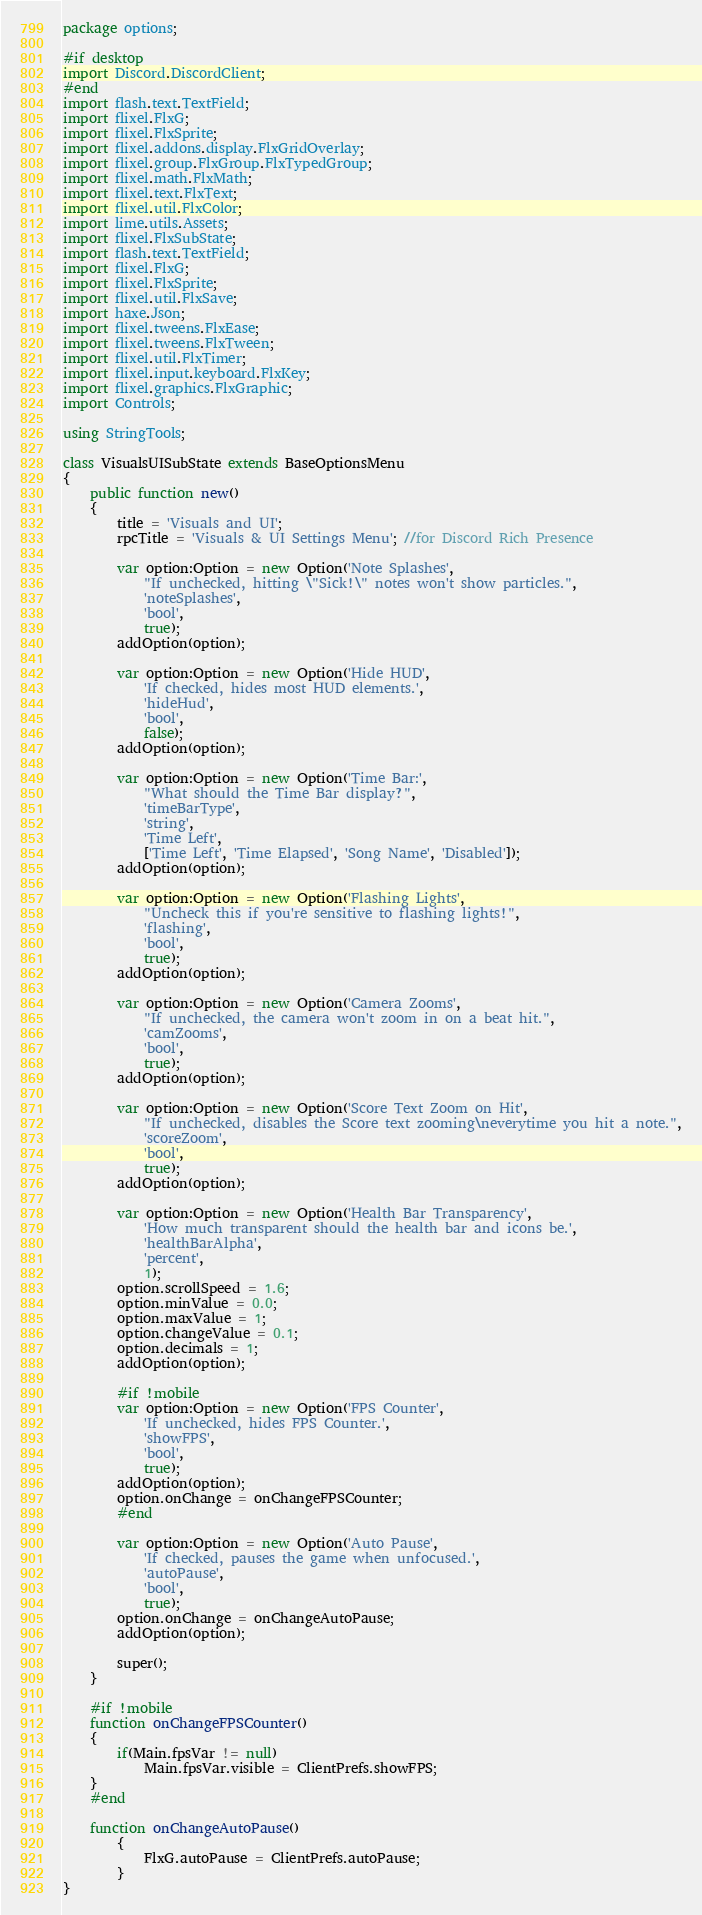<code> <loc_0><loc_0><loc_500><loc_500><_Haxe_>package options;

#if desktop
import Discord.DiscordClient;
#end
import flash.text.TextField;
import flixel.FlxG;
import flixel.FlxSprite;
import flixel.addons.display.FlxGridOverlay;
import flixel.group.FlxGroup.FlxTypedGroup;
import flixel.math.FlxMath;
import flixel.text.FlxText;
import flixel.util.FlxColor;
import lime.utils.Assets;
import flixel.FlxSubState;
import flash.text.TextField;
import flixel.FlxG;
import flixel.FlxSprite;
import flixel.util.FlxSave;
import haxe.Json;
import flixel.tweens.FlxEase;
import flixel.tweens.FlxTween;
import flixel.util.FlxTimer;
import flixel.input.keyboard.FlxKey;
import flixel.graphics.FlxGraphic;
import Controls;

using StringTools;

class VisualsUISubState extends BaseOptionsMenu
{
	public function new()
	{
		title = 'Visuals and UI';
		rpcTitle = 'Visuals & UI Settings Menu'; //for Discord Rich Presence

		var option:Option = new Option('Note Splashes',
			"If unchecked, hitting \"Sick!\" notes won't show particles.",
			'noteSplashes',
			'bool',
			true);
		addOption(option);

		var option:Option = new Option('Hide HUD',
			'If checked, hides most HUD elements.',
			'hideHud',
			'bool',
			false);
		addOption(option);
		
		var option:Option = new Option('Time Bar:',
			"What should the Time Bar display?",
			'timeBarType',
			'string',
			'Time Left',
			['Time Left', 'Time Elapsed', 'Song Name', 'Disabled']);
		addOption(option);

		var option:Option = new Option('Flashing Lights',
			"Uncheck this if you're sensitive to flashing lights!",
			'flashing',
			'bool',
			true);
		addOption(option);

		var option:Option = new Option('Camera Zooms',
			"If unchecked, the camera won't zoom in on a beat hit.",
			'camZooms',
			'bool',
			true);
		addOption(option);

		var option:Option = new Option('Score Text Zoom on Hit',
			"If unchecked, disables the Score text zooming\neverytime you hit a note.",
			'scoreZoom',
			'bool',
			true);
		addOption(option);

		var option:Option = new Option('Health Bar Transparency',
			'How much transparent should the health bar and icons be.',
			'healthBarAlpha',
			'percent',
			1);
		option.scrollSpeed = 1.6;
		option.minValue = 0.0;
		option.maxValue = 1;
		option.changeValue = 0.1;
		option.decimals = 1;
		addOption(option);
		
		#if !mobile
		var option:Option = new Option('FPS Counter',
			'If unchecked, hides FPS Counter.',
			'showFPS',
			'bool',
			true);
		addOption(option);
		option.onChange = onChangeFPSCounter;
		#end

		var option:Option = new Option('Auto Pause',
			'If checked, pauses the game when unfocused.',
			'autoPause',
			'bool',
			true);
		option.onChange = onChangeAutoPause;
		addOption(option);

		super();
	}

	#if !mobile
	function onChangeFPSCounter()
	{
		if(Main.fpsVar != null)
			Main.fpsVar.visible = ClientPrefs.showFPS;
	}
	#end

	function onChangeAutoPause()
		{
			FlxG.autoPause = ClientPrefs.autoPause;
		}
}</code> 